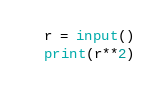<code> <loc_0><loc_0><loc_500><loc_500><_Python_>r = input()
print(r**2)</code> 